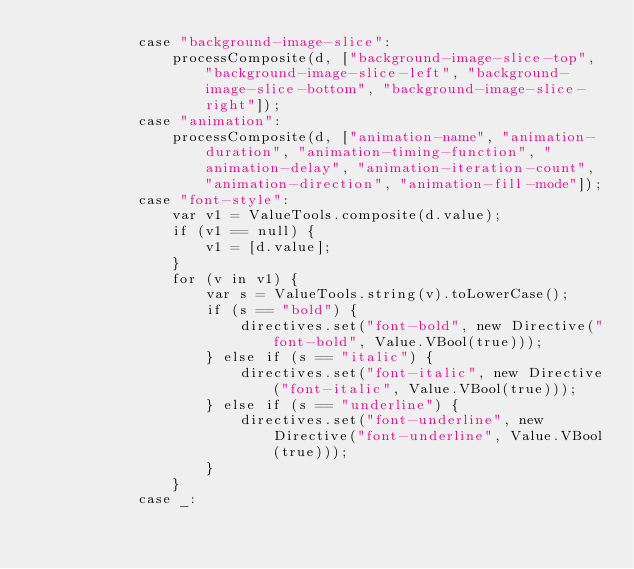Convert code to text. <code><loc_0><loc_0><loc_500><loc_500><_Haxe_>            case "background-image-slice":
                processComposite(d, ["background-image-slice-top", "background-image-slice-left", "background-image-slice-bottom", "background-image-slice-right"]);
            case "animation":
                processComposite(d, ["animation-name", "animation-duration", "animation-timing-function", "animation-delay", "animation-iteration-count", "animation-direction", "animation-fill-mode"]);
            case "font-style":
                var v1 = ValueTools.composite(d.value);
                if (v1 == null) {
                    v1 = [d.value];
                }
                for (v in v1) {
                    var s = ValueTools.string(v).toLowerCase();
                    if (s == "bold") {
                        directives.set("font-bold", new Directive("font-bold", Value.VBool(true)));
                    } else if (s == "italic") {
                        directives.set("font-italic", new Directive("font-italic", Value.VBool(true)));
                    } else if (s == "underline") {
                        directives.set("font-underline", new Directive("font-underline", Value.VBool(true)));
                    }
                }
            case _:</code> 